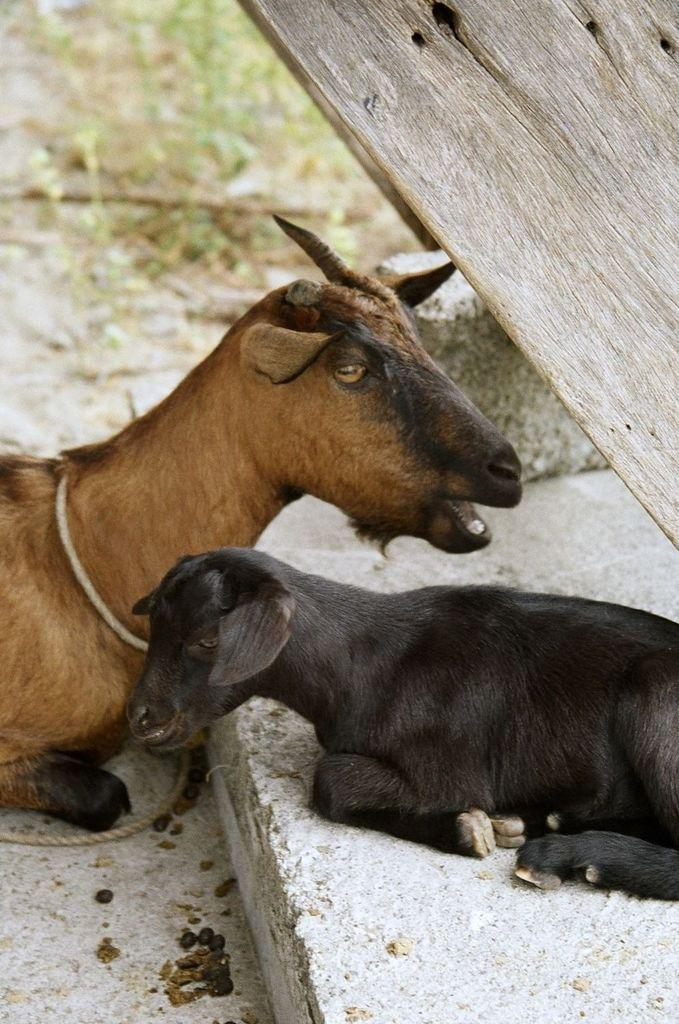What animals are present in the image? There is a goat and a lamb in the image. What are the animals doing in the image? The goat and lamb are sitting. What object can be seen in the image? There appears to be a wooden board in the image. How would you describe the background of the image? The background of the image is blurry. What type of sugar is being used to sweeten the garden in the image? There is no sugar or garden present in the image; it features a goat and a lamb sitting on a wooden board. Is there a woman interacting with the goat and lamb in the image? There is no woman present in the image; it only features a goat and a lamb sitting on a wooden board. 